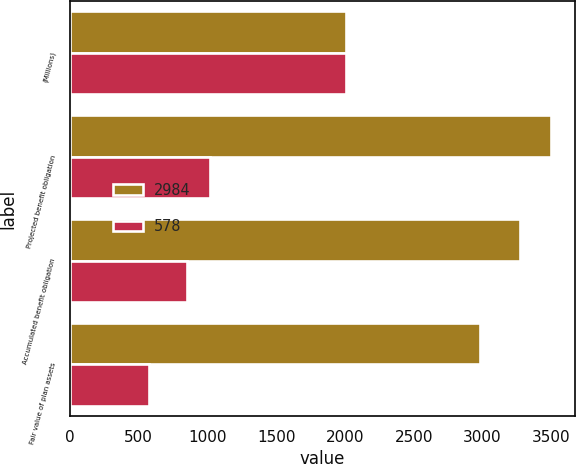Convert chart to OTSL. <chart><loc_0><loc_0><loc_500><loc_500><stacked_bar_chart><ecel><fcel>(Millions)<fcel>Projected benefit obligation<fcel>Accumulated benefit obligation<fcel>Fair value of plan assets<nl><fcel>2984<fcel>2007<fcel>3497<fcel>3271<fcel>2984<nl><fcel>578<fcel>2006<fcel>1020<fcel>854<fcel>578<nl></chart> 